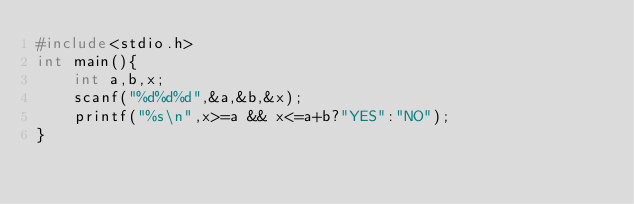Convert code to text. <code><loc_0><loc_0><loc_500><loc_500><_C_>#include<stdio.h>
int main(){
    int a,b,x;
    scanf("%d%d%d",&a,&b,&x);
    printf("%s\n",x>=a && x<=a+b?"YES":"NO");
}</code> 